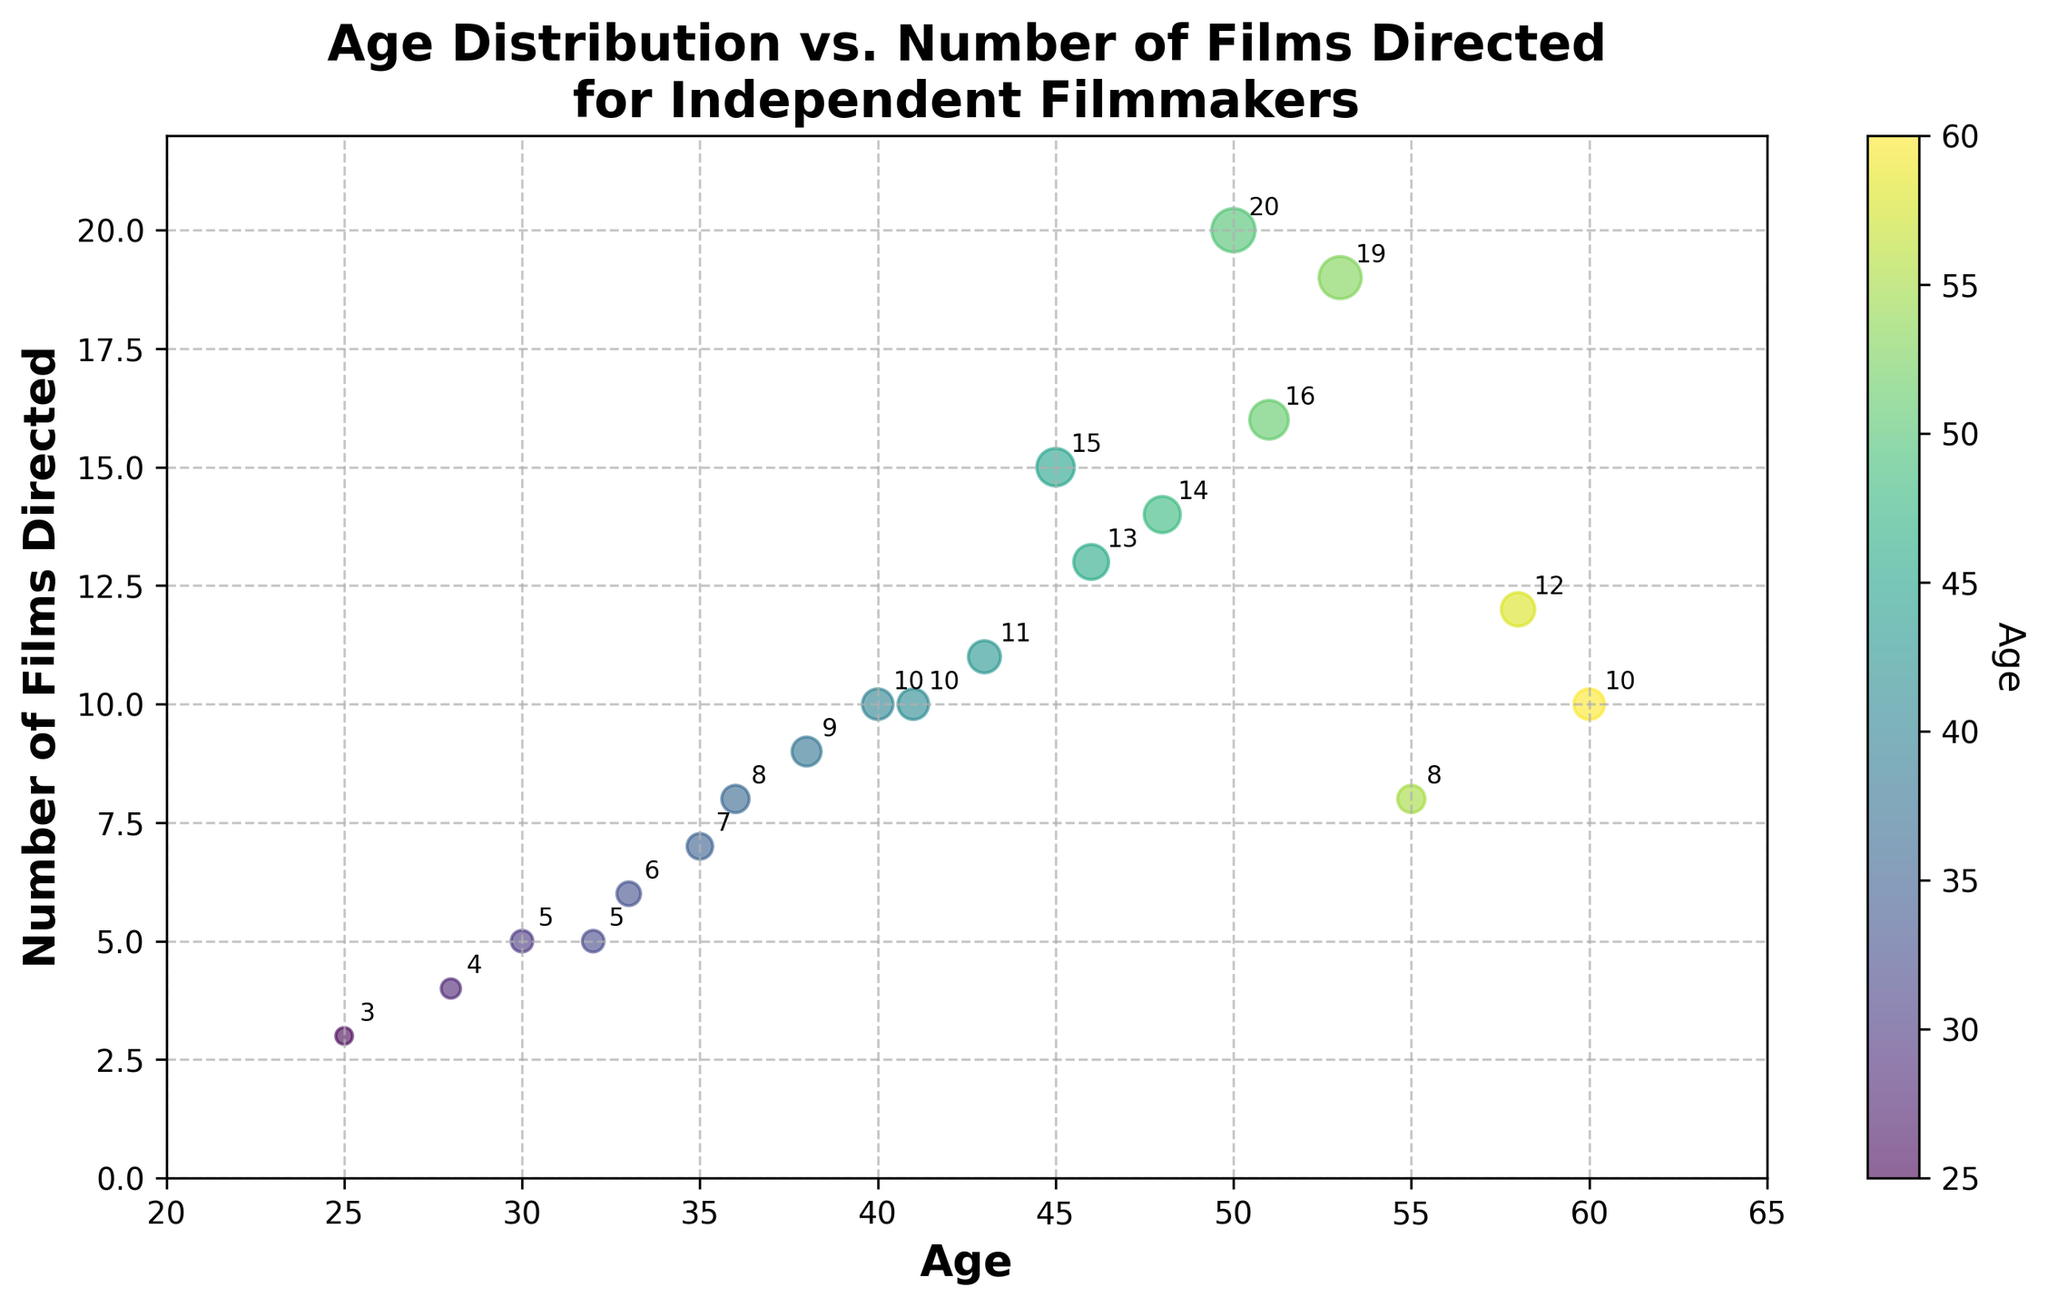How many data points are shown on the scatter plot? To determine the number of data points, count each unique combination of age and number of films directed represented by a dot on the scatter plot. There are 20 data points.
Answer: 20 What is the title of the scatter plot? The title is usually displayed at the top of the scatter plot. It describes the subject being visualized, which in this case is the relationship between age distribution and the number of films directed by independent filmmakers.
Answer: Age Distribution vs. Number of Films Directed for Independent Filmmakers What color represents the youngest age group in the scatter plot? A color bar labeled "Age" helps in identifying the color representation of different ages. In the provided data, the youngest age is 25, which is generally represented by the starting color in the 'viridis' color map.
Answer: The starting color on the 'viridis' scale Which age group appears to have directed the most films? Look for the dot that is plotted highest on the y-axis (representing the number of films directed). The highest number of films directed is 20, which corresponds to the age 50.
Answer: 50 What is the range of ages displayed in the scatter plot? By inspecting the x-axis, you can find the minimum and maximum values of age. The minimum age is 25, and the maximum age is 60.
Answer: 25 to 60 How many films did the 45-year-old filmmaker direct? Locate the point where age equals 45 on the x-axis and see its corresponding y-value.
Answer: 15 What is the average number of films directed by the filmmakers aged over 50? Identify the data points for filmmakers aged over 50 (ages 51, 53, 55, and 58). The corresponding number of films directed are 16, 19, 8, and 12. Calculate the average as (16 + 19 + 8 + 12) / 4 = 13.75.
Answer: 13.75 Are there any age groups where the number of films directed is exactly 10? Check the y-axis at the value 10 and identify the corresponding x-values (ages).
Answer: 40, 41, and 60 Which filmmaker age has the largest number of films directed? Identify the highest y-value on the scatter plot. The highest number of films directed is 20 at age 50.
Answer: Age 50 What is the difference in the number of films directed between the youngest and the oldest filmmakers? Identify the number of films directed by the youngest (25 years) and the oldest (60 years) ages. For 25 years, it is 3 films, and for 60 years, it is 10 films. Calculate the difference: 10 - 3 = 7.
Answer: 7 